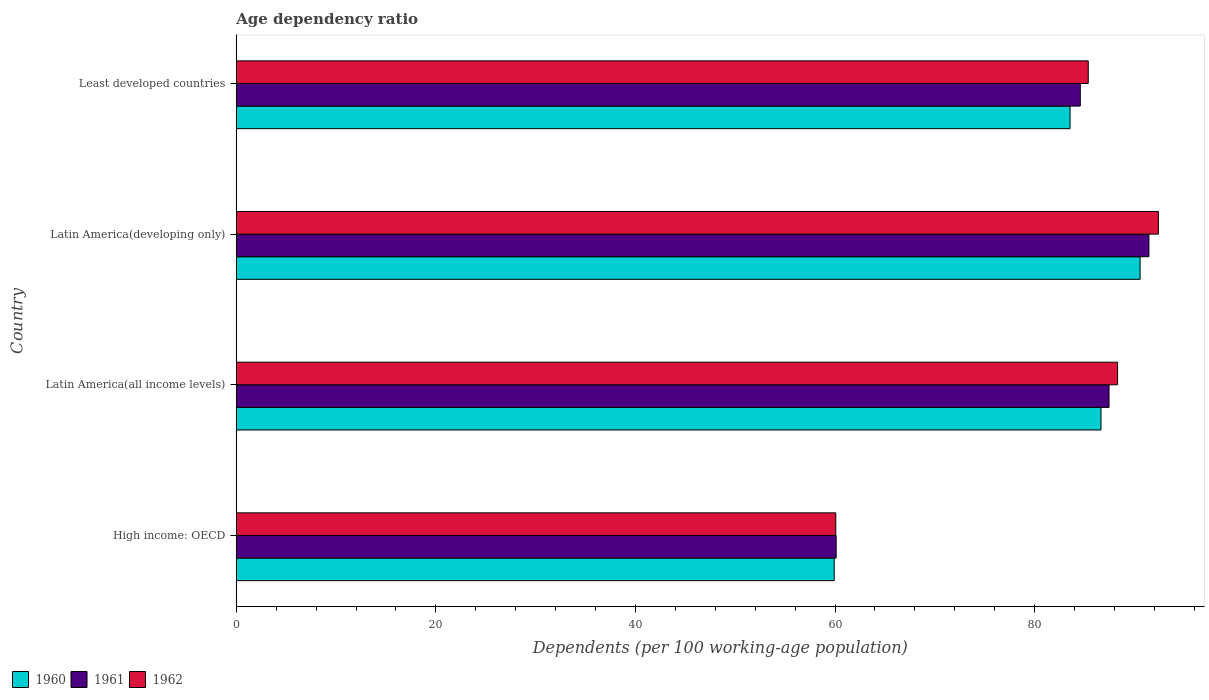How many different coloured bars are there?
Your answer should be compact. 3. How many groups of bars are there?
Give a very brief answer. 4. Are the number of bars on each tick of the Y-axis equal?
Offer a terse response. Yes. How many bars are there on the 2nd tick from the bottom?
Offer a terse response. 3. What is the label of the 3rd group of bars from the top?
Your answer should be compact. Latin America(all income levels). In how many cases, is the number of bars for a given country not equal to the number of legend labels?
Offer a very short reply. 0. What is the age dependency ratio in in 1961 in Latin America(all income levels)?
Keep it short and to the point. 87.45. Across all countries, what is the maximum age dependency ratio in in 1961?
Provide a short and direct response. 91.45. Across all countries, what is the minimum age dependency ratio in in 1962?
Your response must be concise. 60.07. In which country was the age dependency ratio in in 1962 maximum?
Provide a succinct answer. Latin America(developing only). In which country was the age dependency ratio in in 1962 minimum?
Offer a very short reply. High income: OECD. What is the total age dependency ratio in in 1962 in the graph?
Keep it short and to the point. 326.15. What is the difference between the age dependency ratio in in 1962 in High income: OECD and that in Latin America(developing only)?
Your answer should be compact. -32.32. What is the difference between the age dependency ratio in in 1961 in Latin America(developing only) and the age dependency ratio in in 1962 in Least developed countries?
Provide a short and direct response. 6.08. What is the average age dependency ratio in in 1961 per country?
Your answer should be compact. 80.9. What is the difference between the age dependency ratio in in 1961 and age dependency ratio in in 1960 in Latin America(developing only)?
Offer a terse response. 0.89. What is the ratio of the age dependency ratio in in 1961 in High income: OECD to that in Latin America(developing only)?
Provide a succinct answer. 0.66. Is the difference between the age dependency ratio in in 1961 in High income: OECD and Latin America(all income levels) greater than the difference between the age dependency ratio in in 1960 in High income: OECD and Latin America(all income levels)?
Your answer should be compact. No. What is the difference between the highest and the second highest age dependency ratio in in 1961?
Your answer should be compact. 4. What is the difference between the highest and the lowest age dependency ratio in in 1961?
Your answer should be compact. 31.34. In how many countries, is the age dependency ratio in in 1960 greater than the average age dependency ratio in in 1960 taken over all countries?
Keep it short and to the point. 3. Are all the bars in the graph horizontal?
Your response must be concise. Yes. What is the difference between two consecutive major ticks on the X-axis?
Ensure brevity in your answer.  20. Are the values on the major ticks of X-axis written in scientific E-notation?
Your response must be concise. No. Does the graph contain any zero values?
Offer a terse response. No. Where does the legend appear in the graph?
Make the answer very short. Bottom left. How are the legend labels stacked?
Offer a very short reply. Horizontal. What is the title of the graph?
Your response must be concise. Age dependency ratio. What is the label or title of the X-axis?
Ensure brevity in your answer.  Dependents (per 100 working-age population). What is the Dependents (per 100 working-age population) in 1960 in High income: OECD?
Your answer should be very brief. 59.92. What is the Dependents (per 100 working-age population) in 1961 in High income: OECD?
Provide a succinct answer. 60.11. What is the Dependents (per 100 working-age population) of 1962 in High income: OECD?
Keep it short and to the point. 60.07. What is the Dependents (per 100 working-age population) of 1960 in Latin America(all income levels)?
Your response must be concise. 86.65. What is the Dependents (per 100 working-age population) in 1961 in Latin America(all income levels)?
Give a very brief answer. 87.45. What is the Dependents (per 100 working-age population) in 1962 in Latin America(all income levels)?
Keep it short and to the point. 88.31. What is the Dependents (per 100 working-age population) in 1960 in Latin America(developing only)?
Make the answer very short. 90.56. What is the Dependents (per 100 working-age population) in 1961 in Latin America(developing only)?
Offer a terse response. 91.45. What is the Dependents (per 100 working-age population) in 1962 in Latin America(developing only)?
Keep it short and to the point. 92.4. What is the Dependents (per 100 working-age population) in 1960 in Least developed countries?
Make the answer very short. 83.55. What is the Dependents (per 100 working-age population) of 1961 in Least developed countries?
Ensure brevity in your answer.  84.57. What is the Dependents (per 100 working-age population) of 1962 in Least developed countries?
Keep it short and to the point. 85.37. Across all countries, what is the maximum Dependents (per 100 working-age population) in 1960?
Your answer should be very brief. 90.56. Across all countries, what is the maximum Dependents (per 100 working-age population) in 1961?
Provide a succinct answer. 91.45. Across all countries, what is the maximum Dependents (per 100 working-age population) of 1962?
Make the answer very short. 92.4. Across all countries, what is the minimum Dependents (per 100 working-age population) in 1960?
Provide a short and direct response. 59.92. Across all countries, what is the minimum Dependents (per 100 working-age population) in 1961?
Keep it short and to the point. 60.11. Across all countries, what is the minimum Dependents (per 100 working-age population) in 1962?
Keep it short and to the point. 60.07. What is the total Dependents (per 100 working-age population) in 1960 in the graph?
Your response must be concise. 320.67. What is the total Dependents (per 100 working-age population) in 1961 in the graph?
Your response must be concise. 323.59. What is the total Dependents (per 100 working-age population) of 1962 in the graph?
Offer a very short reply. 326.15. What is the difference between the Dependents (per 100 working-age population) in 1960 in High income: OECD and that in Latin America(all income levels)?
Offer a very short reply. -26.73. What is the difference between the Dependents (per 100 working-age population) of 1961 in High income: OECD and that in Latin America(all income levels)?
Provide a succinct answer. -27.34. What is the difference between the Dependents (per 100 working-age population) in 1962 in High income: OECD and that in Latin America(all income levels)?
Your response must be concise. -28.24. What is the difference between the Dependents (per 100 working-age population) in 1960 in High income: OECD and that in Latin America(developing only)?
Your response must be concise. -30.65. What is the difference between the Dependents (per 100 working-age population) of 1961 in High income: OECD and that in Latin America(developing only)?
Ensure brevity in your answer.  -31.34. What is the difference between the Dependents (per 100 working-age population) in 1962 in High income: OECD and that in Latin America(developing only)?
Keep it short and to the point. -32.32. What is the difference between the Dependents (per 100 working-age population) in 1960 in High income: OECD and that in Least developed countries?
Provide a short and direct response. -23.63. What is the difference between the Dependents (per 100 working-age population) in 1961 in High income: OECD and that in Least developed countries?
Your answer should be compact. -24.46. What is the difference between the Dependents (per 100 working-age population) of 1962 in High income: OECD and that in Least developed countries?
Make the answer very short. -25.3. What is the difference between the Dependents (per 100 working-age population) of 1960 in Latin America(all income levels) and that in Latin America(developing only)?
Ensure brevity in your answer.  -3.92. What is the difference between the Dependents (per 100 working-age population) in 1961 in Latin America(all income levels) and that in Latin America(developing only)?
Offer a very short reply. -4. What is the difference between the Dependents (per 100 working-age population) in 1962 in Latin America(all income levels) and that in Latin America(developing only)?
Keep it short and to the point. -4.09. What is the difference between the Dependents (per 100 working-age population) of 1960 in Latin America(all income levels) and that in Least developed countries?
Your response must be concise. 3.1. What is the difference between the Dependents (per 100 working-age population) of 1961 in Latin America(all income levels) and that in Least developed countries?
Make the answer very short. 2.88. What is the difference between the Dependents (per 100 working-age population) in 1962 in Latin America(all income levels) and that in Least developed countries?
Your answer should be very brief. 2.94. What is the difference between the Dependents (per 100 working-age population) in 1960 in Latin America(developing only) and that in Least developed countries?
Offer a very short reply. 7.02. What is the difference between the Dependents (per 100 working-age population) in 1961 in Latin America(developing only) and that in Least developed countries?
Keep it short and to the point. 6.88. What is the difference between the Dependents (per 100 working-age population) of 1962 in Latin America(developing only) and that in Least developed countries?
Ensure brevity in your answer.  7.03. What is the difference between the Dependents (per 100 working-age population) in 1960 in High income: OECD and the Dependents (per 100 working-age population) in 1961 in Latin America(all income levels)?
Your answer should be very brief. -27.54. What is the difference between the Dependents (per 100 working-age population) of 1960 in High income: OECD and the Dependents (per 100 working-age population) of 1962 in Latin America(all income levels)?
Offer a terse response. -28.39. What is the difference between the Dependents (per 100 working-age population) in 1961 in High income: OECD and the Dependents (per 100 working-age population) in 1962 in Latin America(all income levels)?
Your response must be concise. -28.2. What is the difference between the Dependents (per 100 working-age population) of 1960 in High income: OECD and the Dependents (per 100 working-age population) of 1961 in Latin America(developing only)?
Keep it short and to the point. -31.53. What is the difference between the Dependents (per 100 working-age population) in 1960 in High income: OECD and the Dependents (per 100 working-age population) in 1962 in Latin America(developing only)?
Make the answer very short. -32.48. What is the difference between the Dependents (per 100 working-age population) in 1961 in High income: OECD and the Dependents (per 100 working-age population) in 1962 in Latin America(developing only)?
Offer a terse response. -32.29. What is the difference between the Dependents (per 100 working-age population) of 1960 in High income: OECD and the Dependents (per 100 working-age population) of 1961 in Least developed countries?
Your answer should be compact. -24.66. What is the difference between the Dependents (per 100 working-age population) of 1960 in High income: OECD and the Dependents (per 100 working-age population) of 1962 in Least developed countries?
Offer a terse response. -25.45. What is the difference between the Dependents (per 100 working-age population) of 1961 in High income: OECD and the Dependents (per 100 working-age population) of 1962 in Least developed countries?
Offer a very short reply. -25.26. What is the difference between the Dependents (per 100 working-age population) in 1960 in Latin America(all income levels) and the Dependents (per 100 working-age population) in 1961 in Latin America(developing only)?
Your answer should be compact. -4.8. What is the difference between the Dependents (per 100 working-age population) in 1960 in Latin America(all income levels) and the Dependents (per 100 working-age population) in 1962 in Latin America(developing only)?
Ensure brevity in your answer.  -5.75. What is the difference between the Dependents (per 100 working-age population) in 1961 in Latin America(all income levels) and the Dependents (per 100 working-age population) in 1962 in Latin America(developing only)?
Offer a very short reply. -4.94. What is the difference between the Dependents (per 100 working-age population) of 1960 in Latin America(all income levels) and the Dependents (per 100 working-age population) of 1961 in Least developed countries?
Provide a succinct answer. 2.07. What is the difference between the Dependents (per 100 working-age population) of 1960 in Latin America(all income levels) and the Dependents (per 100 working-age population) of 1962 in Least developed countries?
Make the answer very short. 1.28. What is the difference between the Dependents (per 100 working-age population) of 1961 in Latin America(all income levels) and the Dependents (per 100 working-age population) of 1962 in Least developed countries?
Offer a terse response. 2.08. What is the difference between the Dependents (per 100 working-age population) in 1960 in Latin America(developing only) and the Dependents (per 100 working-age population) in 1961 in Least developed countries?
Provide a succinct answer. 5.99. What is the difference between the Dependents (per 100 working-age population) of 1960 in Latin America(developing only) and the Dependents (per 100 working-age population) of 1962 in Least developed countries?
Ensure brevity in your answer.  5.19. What is the difference between the Dependents (per 100 working-age population) of 1961 in Latin America(developing only) and the Dependents (per 100 working-age population) of 1962 in Least developed countries?
Provide a succinct answer. 6.08. What is the average Dependents (per 100 working-age population) in 1960 per country?
Provide a short and direct response. 80.17. What is the average Dependents (per 100 working-age population) of 1961 per country?
Your answer should be very brief. 80.9. What is the average Dependents (per 100 working-age population) of 1962 per country?
Provide a short and direct response. 81.54. What is the difference between the Dependents (per 100 working-age population) in 1960 and Dependents (per 100 working-age population) in 1961 in High income: OECD?
Your answer should be compact. -0.2. What is the difference between the Dependents (per 100 working-age population) of 1960 and Dependents (per 100 working-age population) of 1962 in High income: OECD?
Your response must be concise. -0.16. What is the difference between the Dependents (per 100 working-age population) of 1961 and Dependents (per 100 working-age population) of 1962 in High income: OECD?
Give a very brief answer. 0.04. What is the difference between the Dependents (per 100 working-age population) of 1960 and Dependents (per 100 working-age population) of 1961 in Latin America(all income levels)?
Keep it short and to the point. -0.81. What is the difference between the Dependents (per 100 working-age population) of 1960 and Dependents (per 100 working-age population) of 1962 in Latin America(all income levels)?
Offer a very short reply. -1.66. What is the difference between the Dependents (per 100 working-age population) of 1961 and Dependents (per 100 working-age population) of 1962 in Latin America(all income levels)?
Your answer should be compact. -0.86. What is the difference between the Dependents (per 100 working-age population) in 1960 and Dependents (per 100 working-age population) in 1961 in Latin America(developing only)?
Make the answer very short. -0.89. What is the difference between the Dependents (per 100 working-age population) in 1960 and Dependents (per 100 working-age population) in 1962 in Latin America(developing only)?
Keep it short and to the point. -1.83. What is the difference between the Dependents (per 100 working-age population) of 1961 and Dependents (per 100 working-age population) of 1962 in Latin America(developing only)?
Ensure brevity in your answer.  -0.95. What is the difference between the Dependents (per 100 working-age population) in 1960 and Dependents (per 100 working-age population) in 1961 in Least developed countries?
Your answer should be compact. -1.03. What is the difference between the Dependents (per 100 working-age population) in 1960 and Dependents (per 100 working-age population) in 1962 in Least developed countries?
Your answer should be compact. -1.82. What is the difference between the Dependents (per 100 working-age population) of 1961 and Dependents (per 100 working-age population) of 1962 in Least developed countries?
Provide a succinct answer. -0.8. What is the ratio of the Dependents (per 100 working-age population) in 1960 in High income: OECD to that in Latin America(all income levels)?
Offer a terse response. 0.69. What is the ratio of the Dependents (per 100 working-age population) of 1961 in High income: OECD to that in Latin America(all income levels)?
Provide a succinct answer. 0.69. What is the ratio of the Dependents (per 100 working-age population) in 1962 in High income: OECD to that in Latin America(all income levels)?
Keep it short and to the point. 0.68. What is the ratio of the Dependents (per 100 working-age population) in 1960 in High income: OECD to that in Latin America(developing only)?
Your answer should be compact. 0.66. What is the ratio of the Dependents (per 100 working-age population) of 1961 in High income: OECD to that in Latin America(developing only)?
Offer a terse response. 0.66. What is the ratio of the Dependents (per 100 working-age population) of 1962 in High income: OECD to that in Latin America(developing only)?
Your answer should be compact. 0.65. What is the ratio of the Dependents (per 100 working-age population) in 1960 in High income: OECD to that in Least developed countries?
Keep it short and to the point. 0.72. What is the ratio of the Dependents (per 100 working-age population) in 1961 in High income: OECD to that in Least developed countries?
Offer a very short reply. 0.71. What is the ratio of the Dependents (per 100 working-age population) of 1962 in High income: OECD to that in Least developed countries?
Offer a very short reply. 0.7. What is the ratio of the Dependents (per 100 working-age population) in 1960 in Latin America(all income levels) to that in Latin America(developing only)?
Ensure brevity in your answer.  0.96. What is the ratio of the Dependents (per 100 working-age population) of 1961 in Latin America(all income levels) to that in Latin America(developing only)?
Offer a very short reply. 0.96. What is the ratio of the Dependents (per 100 working-age population) in 1962 in Latin America(all income levels) to that in Latin America(developing only)?
Ensure brevity in your answer.  0.96. What is the ratio of the Dependents (per 100 working-age population) of 1960 in Latin America(all income levels) to that in Least developed countries?
Provide a succinct answer. 1.04. What is the ratio of the Dependents (per 100 working-age population) in 1961 in Latin America(all income levels) to that in Least developed countries?
Keep it short and to the point. 1.03. What is the ratio of the Dependents (per 100 working-age population) in 1962 in Latin America(all income levels) to that in Least developed countries?
Offer a very short reply. 1.03. What is the ratio of the Dependents (per 100 working-age population) of 1960 in Latin America(developing only) to that in Least developed countries?
Ensure brevity in your answer.  1.08. What is the ratio of the Dependents (per 100 working-age population) of 1961 in Latin America(developing only) to that in Least developed countries?
Your answer should be very brief. 1.08. What is the ratio of the Dependents (per 100 working-age population) of 1962 in Latin America(developing only) to that in Least developed countries?
Make the answer very short. 1.08. What is the difference between the highest and the second highest Dependents (per 100 working-age population) of 1960?
Make the answer very short. 3.92. What is the difference between the highest and the second highest Dependents (per 100 working-age population) of 1961?
Give a very brief answer. 4. What is the difference between the highest and the second highest Dependents (per 100 working-age population) in 1962?
Make the answer very short. 4.09. What is the difference between the highest and the lowest Dependents (per 100 working-age population) in 1960?
Provide a short and direct response. 30.65. What is the difference between the highest and the lowest Dependents (per 100 working-age population) of 1961?
Keep it short and to the point. 31.34. What is the difference between the highest and the lowest Dependents (per 100 working-age population) of 1962?
Provide a succinct answer. 32.32. 